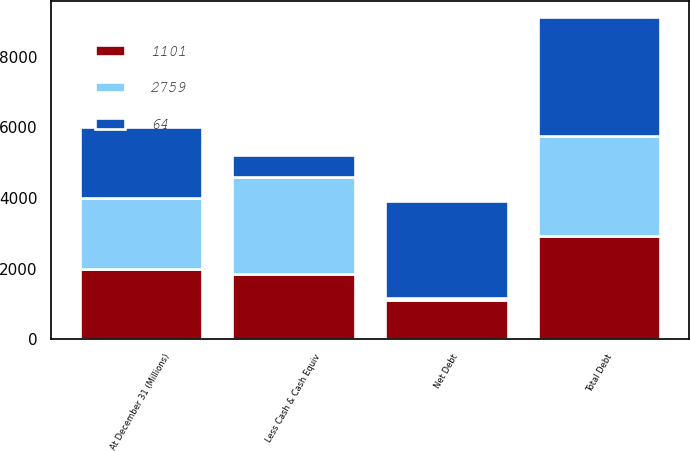<chart> <loc_0><loc_0><loc_500><loc_500><stacked_bar_chart><ecel><fcel>At December 31 (Millions)<fcel>Total Debt<fcel>Less Cash & Cash Equiv<fcel>Net Debt<nl><fcel>2759<fcel>2004<fcel>2821<fcel>2757<fcel>64<nl><fcel>1101<fcel>2003<fcel>2937<fcel>1836<fcel>1101<nl><fcel>64<fcel>2002<fcel>3377<fcel>618<fcel>2759<nl></chart> 